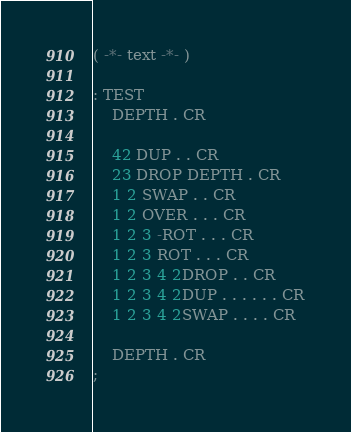Convert code to text. <code><loc_0><loc_0><loc_500><loc_500><_FORTRAN_>( -*- text -*- )

: TEST
	DEPTH . CR

	42 DUP . . CR
	23 DROP DEPTH . CR
	1 2 SWAP . . CR
	1 2 OVER . . . CR
	1 2 3 -ROT . . . CR
	1 2 3 ROT . . . CR
	1 2 3 4 2DROP . . CR
	1 2 3 4 2DUP . . . . . . CR
	1 2 3 4 2SWAP . . . . CR

	DEPTH . CR
;
</code> 